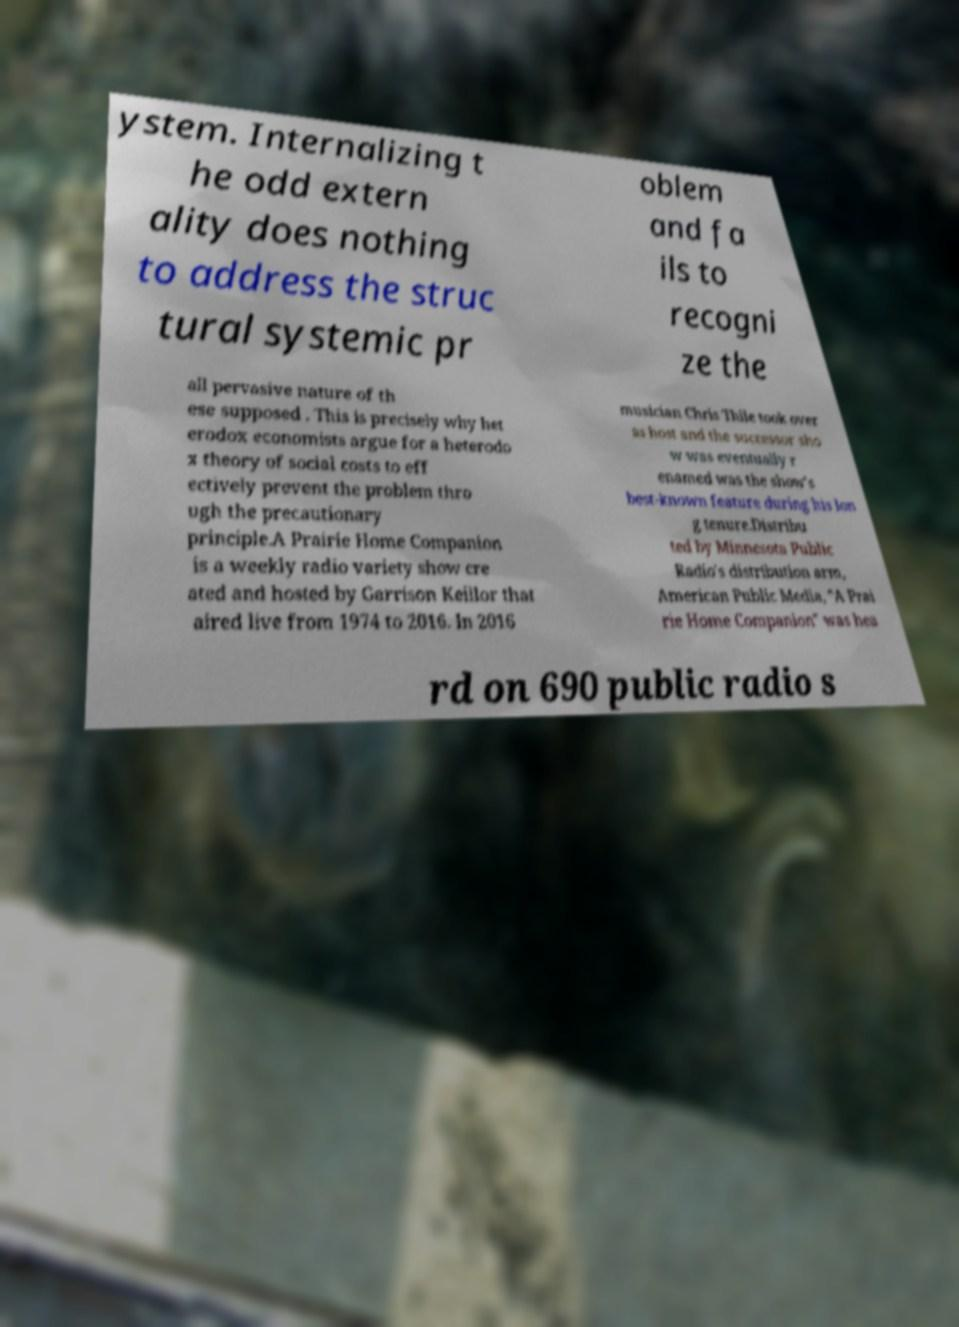I need the written content from this picture converted into text. Can you do that? ystem. Internalizing t he odd extern ality does nothing to address the struc tural systemic pr oblem and fa ils to recogni ze the all pervasive nature of th ese supposed . This is precisely why het erodox economists argue for a heterodo x theory of social costs to eff ectively prevent the problem thro ugh the precautionary principle.A Prairie Home Companion is a weekly radio variety show cre ated and hosted by Garrison Keillor that aired live from 1974 to 2016. In 2016 musician Chris Thile took over as host and the successor sho w was eventually r enamed was the show's best-known feature during his lon g tenure.Distribu ted by Minnesota Public Radio's distribution arm, American Public Media, "A Prai rie Home Companion" was hea rd on 690 public radio s 